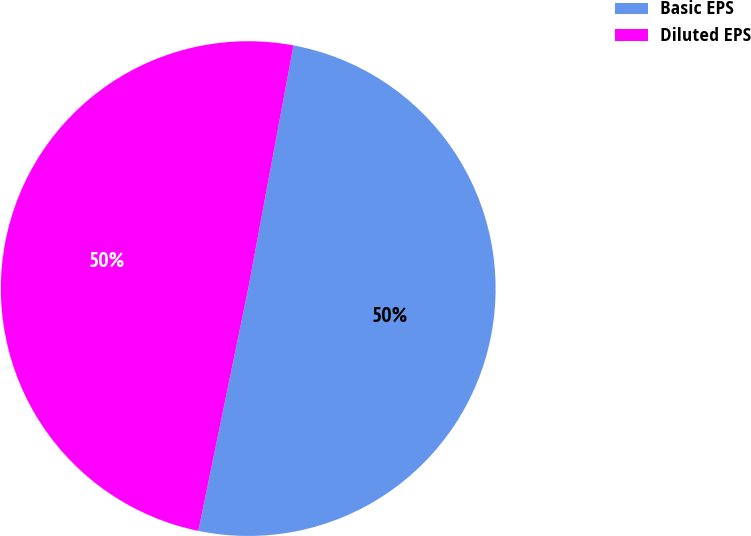<chart> <loc_0><loc_0><loc_500><loc_500><pie_chart><fcel>Basic EPS<fcel>Diluted EPS<nl><fcel>50.3%<fcel>49.7%<nl></chart> 